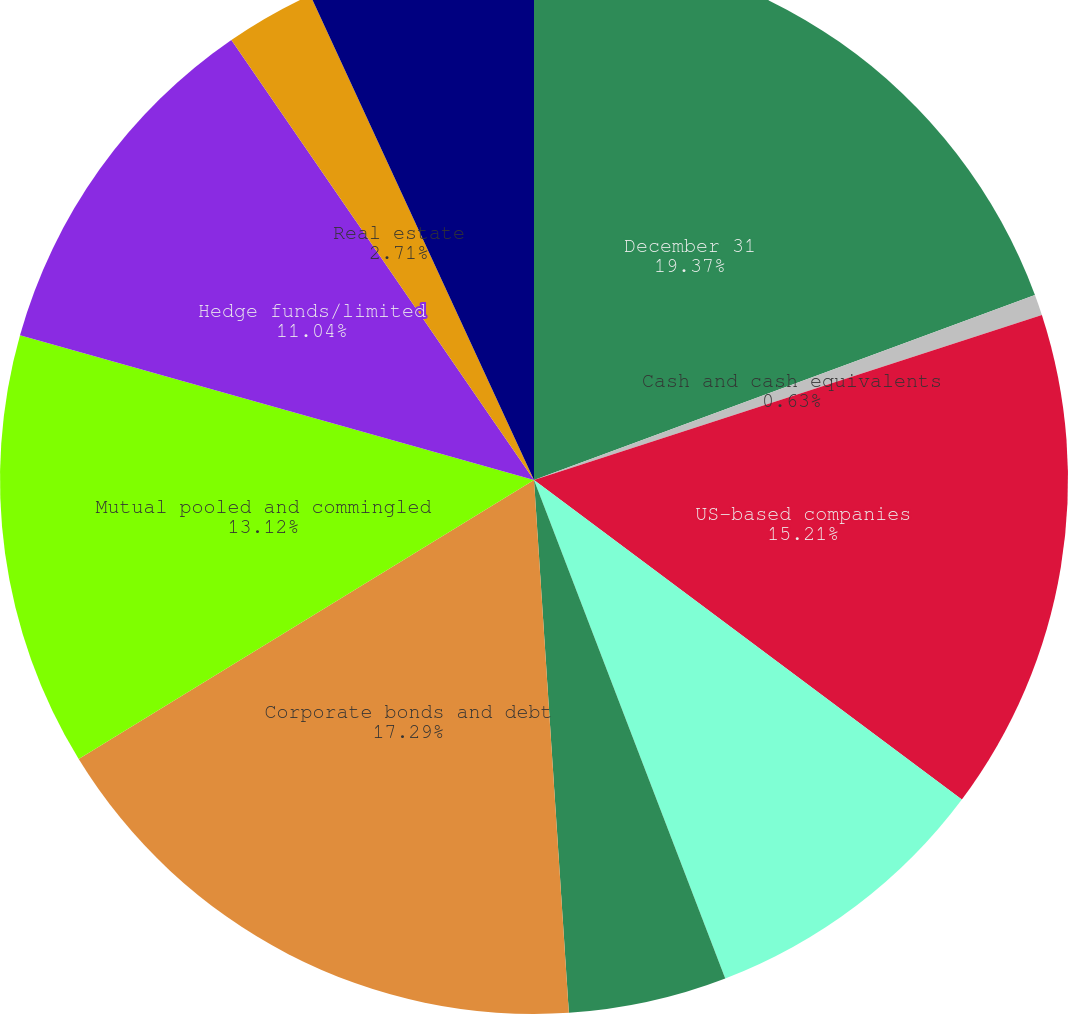Convert chart. <chart><loc_0><loc_0><loc_500><loc_500><pie_chart><fcel>December 31<fcel>Cash and cash equivalents<fcel>US-based companies<fcel>International-based companies<fcel>Government bonds<fcel>Corporate bonds and debt<fcel>Mutual pooled and commingled<fcel>Hedge funds/limited<fcel>Real estate<fcel>Other<nl><fcel>19.37%<fcel>0.63%<fcel>15.21%<fcel>8.96%<fcel>4.79%<fcel>17.29%<fcel>13.12%<fcel>11.04%<fcel>2.71%<fcel>6.88%<nl></chart> 